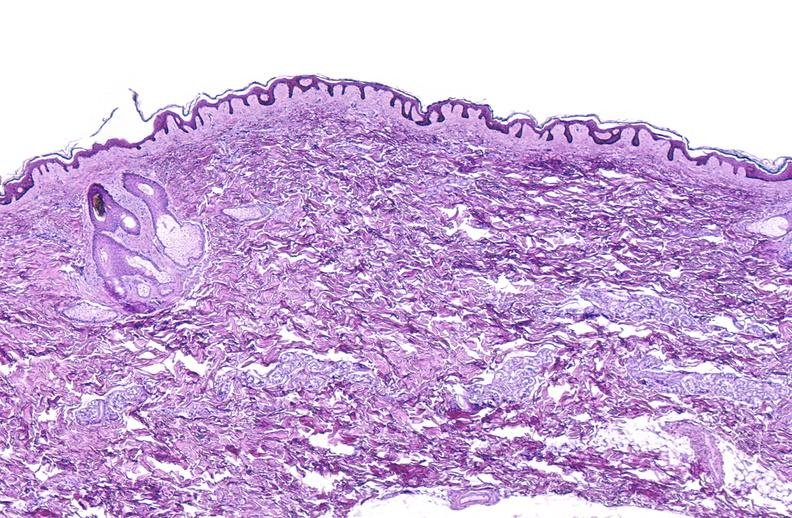does premature coronary disease show scleroderma?
Answer the question using a single word or phrase. No 